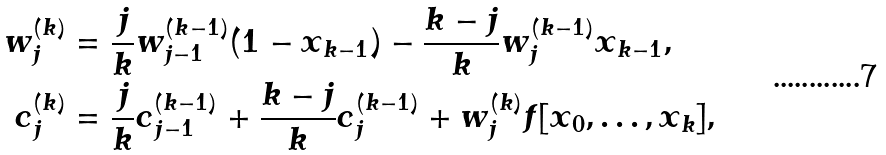Convert formula to latex. <formula><loc_0><loc_0><loc_500><loc_500>w _ { j } ^ { ( k ) } & = \frac { j } { k } w _ { j - 1 } ^ { ( k - 1 ) } ( 1 - x _ { k - 1 } ) - \frac { k - j } { k } w _ { j } ^ { ( k - 1 ) } x _ { k - 1 } , \\ c _ { j } ^ { ( k ) } & = \frac { j } { k } c _ { j - 1 } ^ { ( k - 1 ) } + \frac { k - j } { k } c _ { j } ^ { ( k - 1 ) } + w _ { j } ^ { ( k ) } f [ x _ { 0 } , \dots , x _ { k } ] ,</formula> 